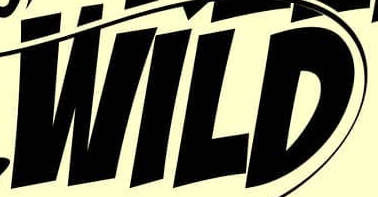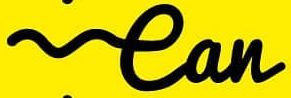What text is displayed in these images sequentially, separated by a semicolon? WILD; ean 